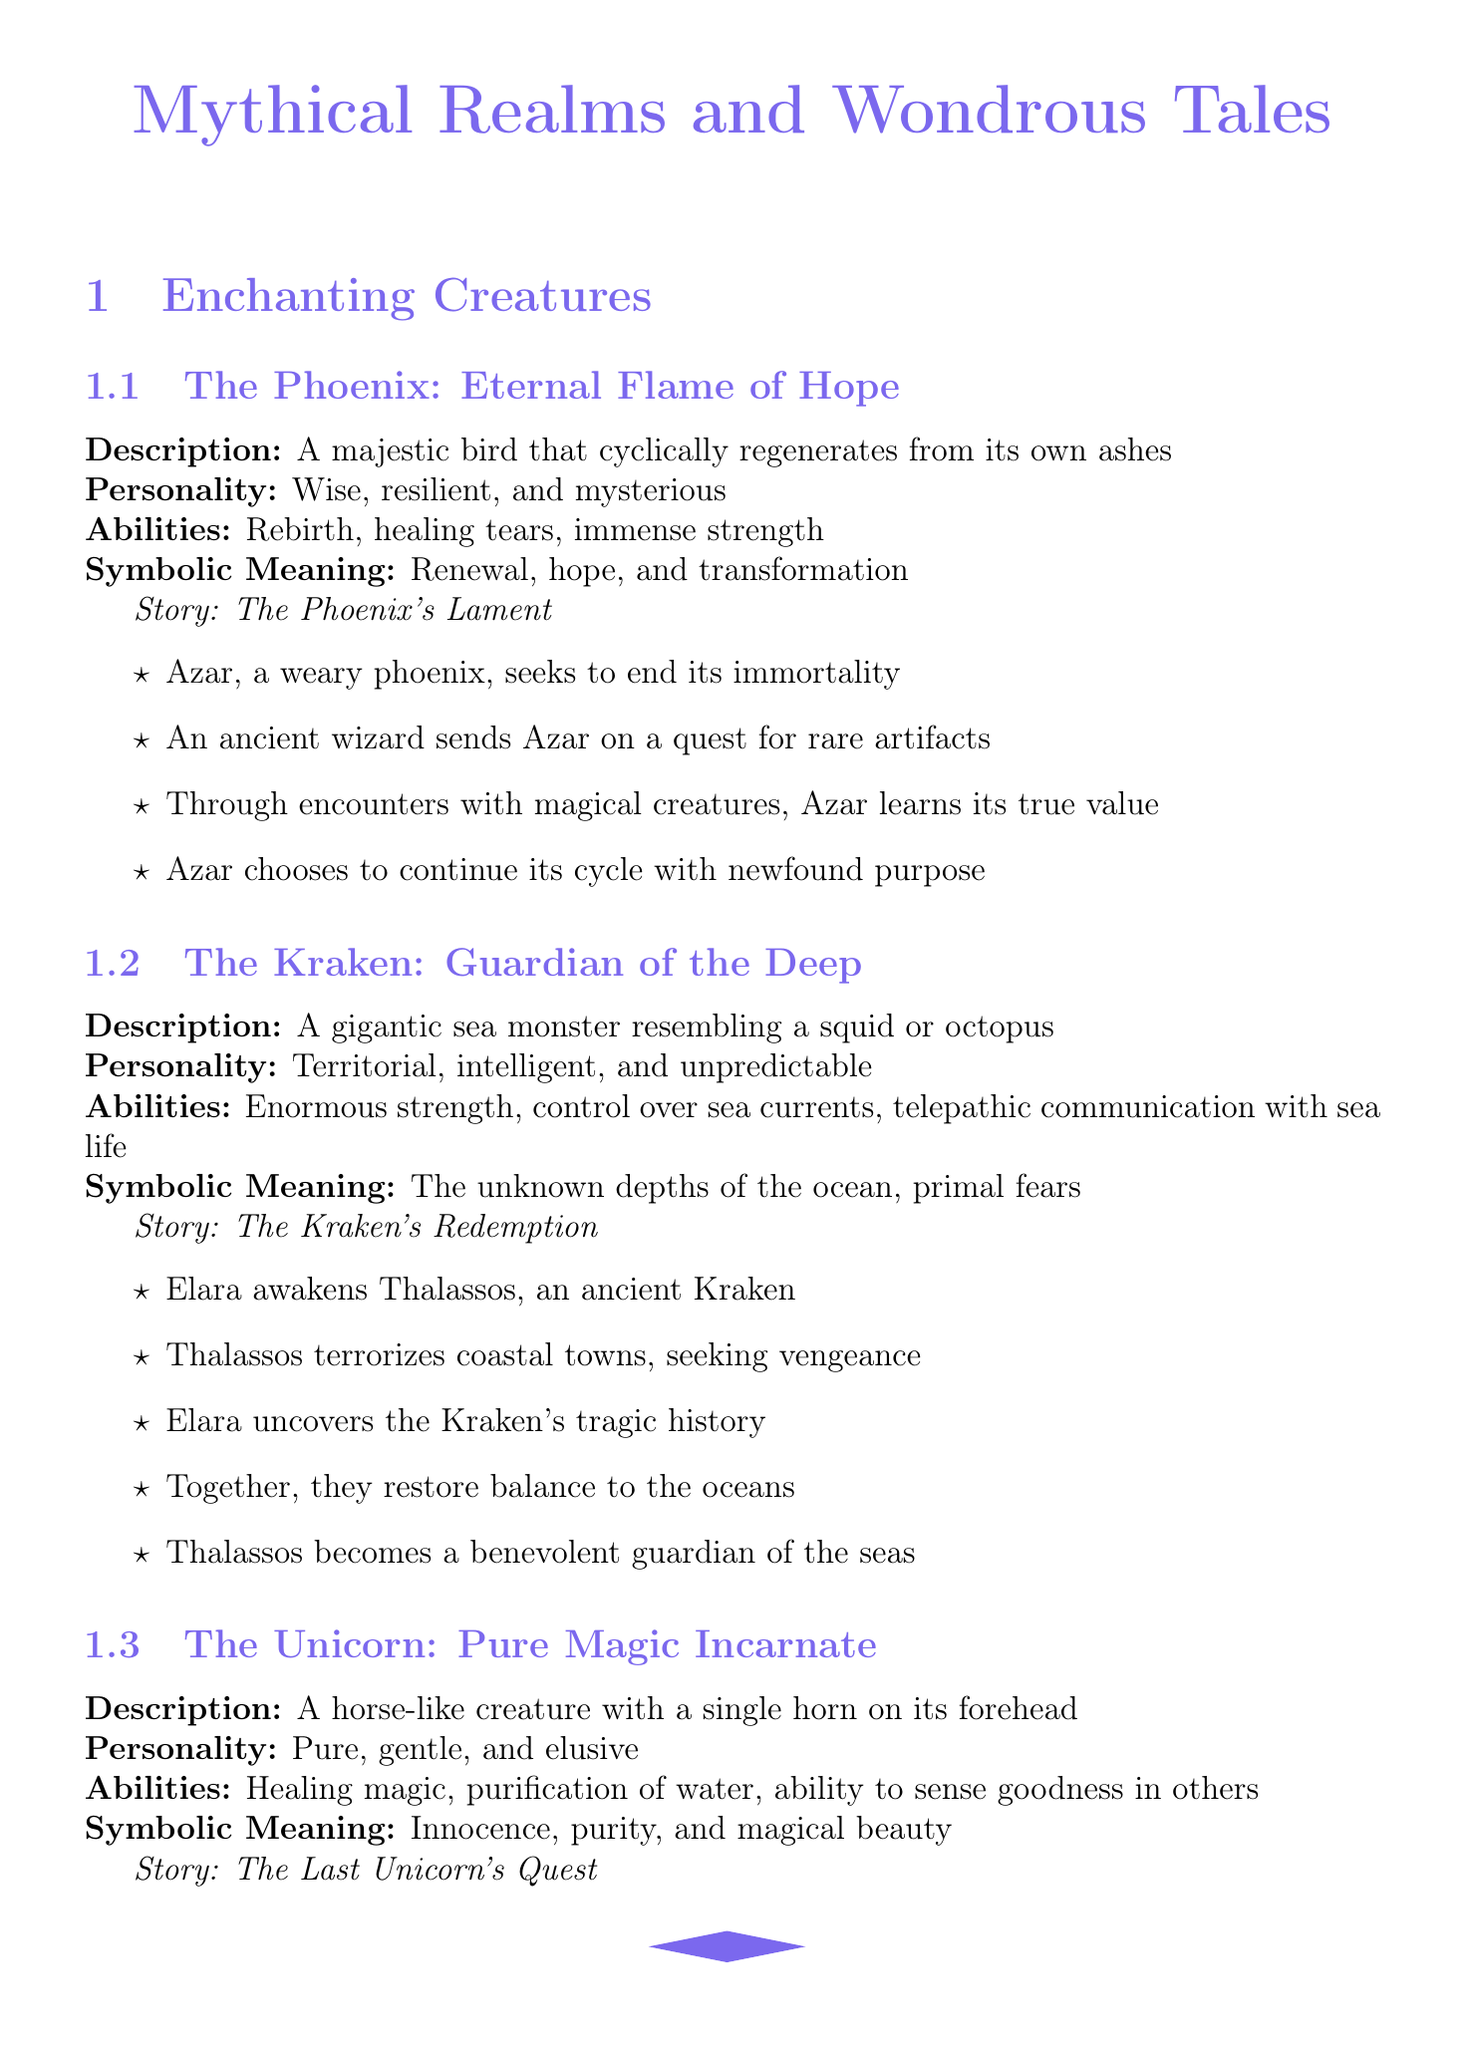What is the name of the phoenix? The document states that the phoenix is named Azar.
Answer: Azar What magical abilities does the kraken possess? The kraken's abilities include enormous strength, control over sea currents, and telepathic communication with sea life.
Answer: Enormous strength, control over sea currents, telepathic communication with sea life What realm is described as a floating archipelago? The document lists Aether as the realm that is a floating archipelago of islands in the sky.
Answer: Aether What is the title of the unicorn's storyline? The storyline for the unicorn is titled "The Last Unicorn's Quest."
Answer: The Last Unicorn's Quest Which theme explores the power of imagination? The thematic element discussing the power of imagination relates to how storytelling shapes reality.
Answer: The power of imagination What storytelling technique involves unreliable narrators? The technique that uses unreliable narrators is explicitly mentioned as adding mystery to tales.
Answer: Unreliable narrator What is the description of Avalon? Avalon is described as a mystical island shrouded in mist, home to powerful fae and magical creatures.
Answer: A mystical island shrouded in mist How many magical systems are listed in the document? The document outlines three magical systems: Elemental Harmony, Runic Inscriptions, and Soulbinding.
Answer: Three 